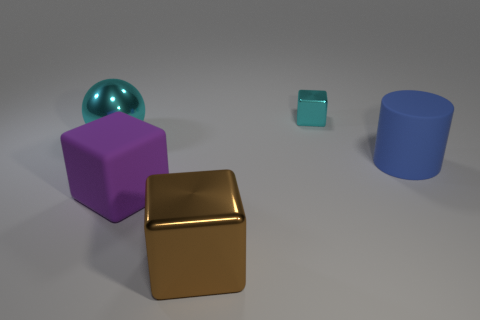Is the size of the blue cylinder the same as the brown metallic cube?
Your response must be concise. Yes. What number of other objects are the same shape as the large cyan metal object?
Provide a short and direct response. 0. There is a rubber thing that is on the left side of the tiny cyan thing; what is its shape?
Offer a very short reply. Cube. Do the large rubber thing that is on the left side of the tiny cyan object and the cyan shiny thing right of the cyan sphere have the same shape?
Provide a succinct answer. Yes. Is the number of metallic spheres that are to the right of the brown shiny block the same as the number of large purple objects?
Your answer should be compact. No. Is there any other thing that is the same size as the brown metallic cube?
Your response must be concise. Yes. There is a small cyan thing that is the same shape as the large brown thing; what material is it?
Provide a short and direct response. Metal. What shape is the shiny object that is to the left of the object in front of the purple thing?
Your answer should be very brief. Sphere. Is the block that is behind the blue matte cylinder made of the same material as the big purple cube?
Provide a succinct answer. No. Are there an equal number of purple things on the right side of the large rubber cylinder and rubber objects right of the cyan cube?
Your response must be concise. No. 